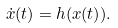<formula> <loc_0><loc_0><loc_500><loc_500>\dot { x } ( t ) = h ( x ( t ) ) .</formula> 